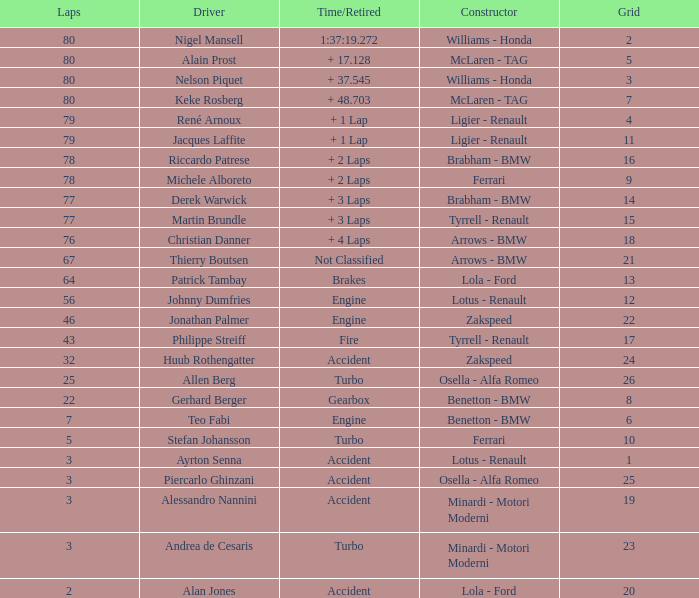What is the time/retired for thierry boutsen? Not Classified. 